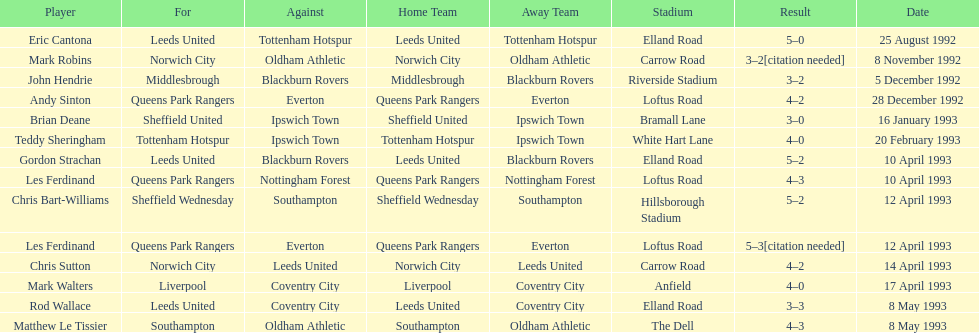Southampton played on may 8th, 1993, who was their opponent? Oldham Athletic. 